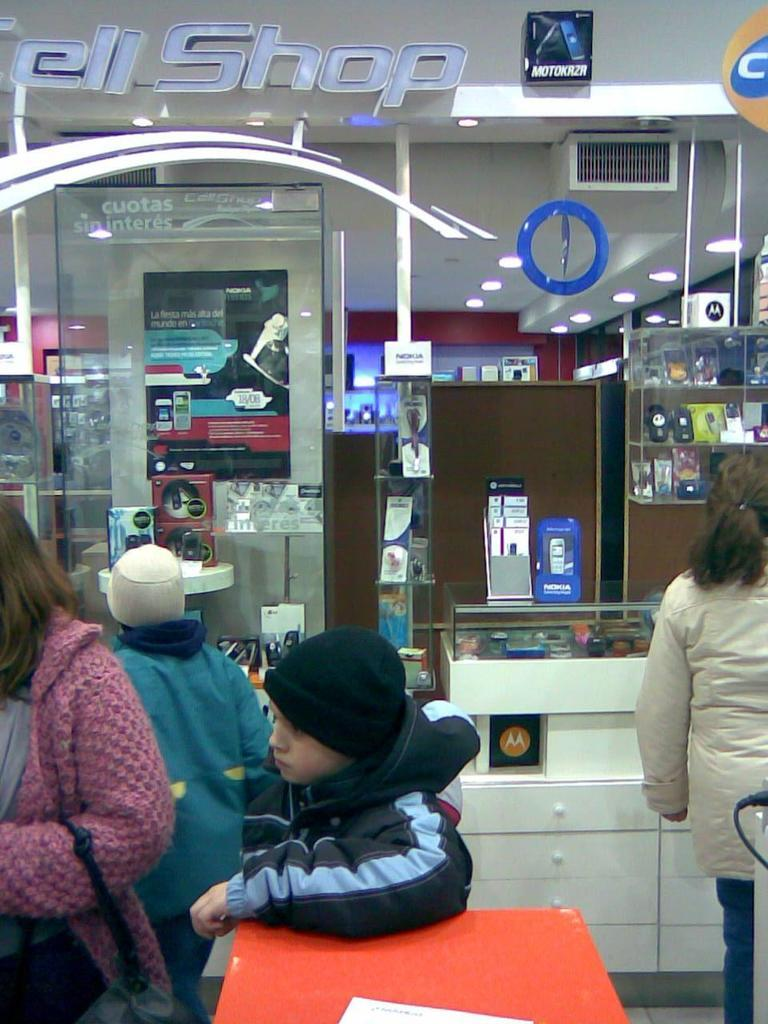<image>
Offer a succinct explanation of the picture presented. the inside of a building with a sign in it that says 'cell shop' 